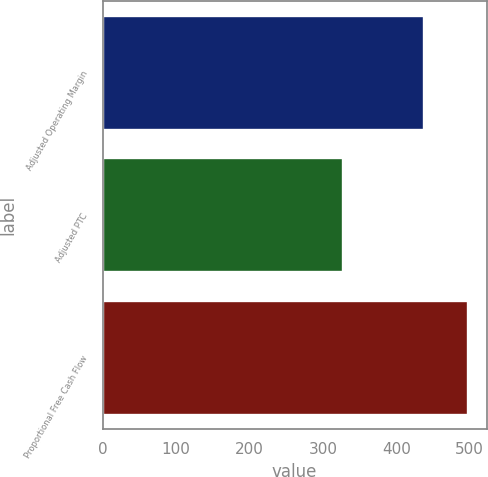Convert chart to OTSL. <chart><loc_0><loc_0><loc_500><loc_500><bar_chart><fcel>Adjusted Operating Margin<fcel>Adjusted PTC<fcel>Proportional Free Cash Flow<nl><fcel>438<fcel>327<fcel>498<nl></chart> 